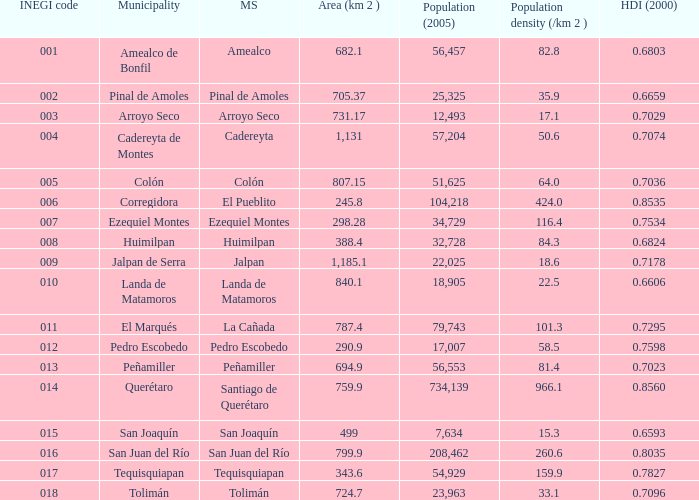WHat is the amount of Human Development Index (2000) that has a Population (2005) of 54,929, and an Area (km 2 ) larger than 343.6? 0.0. 